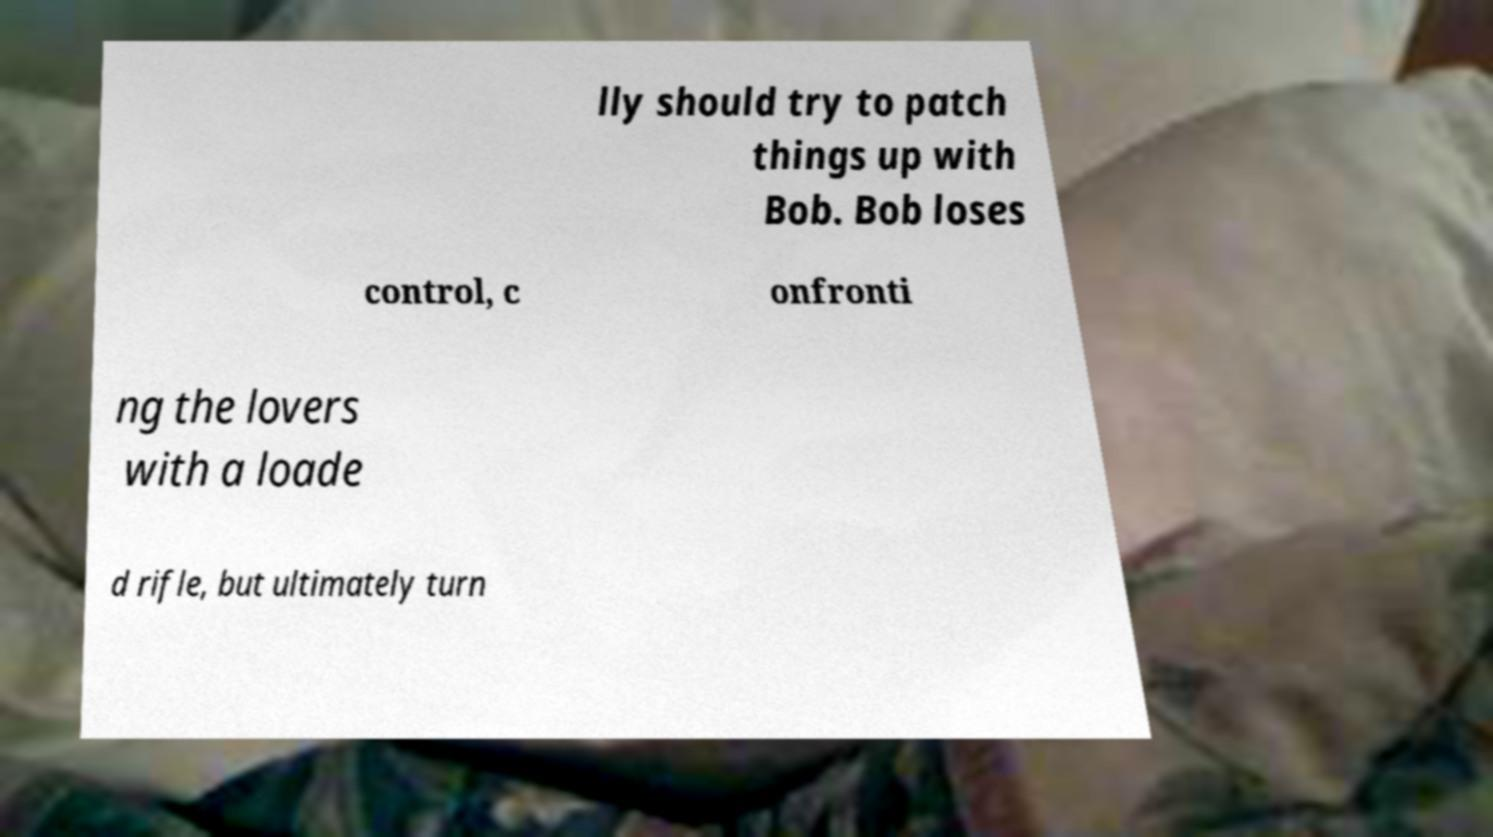I need the written content from this picture converted into text. Can you do that? lly should try to patch things up with Bob. Bob loses control, c onfronti ng the lovers with a loade d rifle, but ultimately turn 